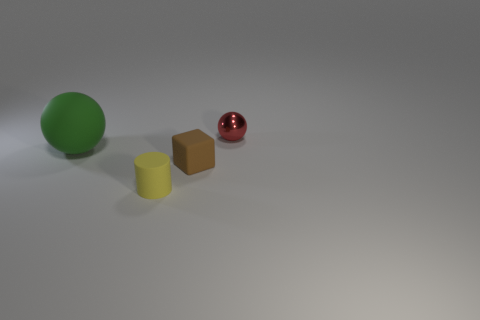Is there a cyan object that has the same size as the metal ball?
Your answer should be very brief. No. What is the material of the small thing that is right of the yellow thing and left of the red metallic sphere?
Make the answer very short. Rubber. How many shiny objects are either tiny blue cylinders or brown cubes?
Offer a very short reply. 0. There is another large object that is made of the same material as the brown thing; what is its shape?
Your answer should be compact. Sphere. What number of tiny matte objects are both in front of the tiny brown cube and behind the yellow rubber cylinder?
Give a very brief answer. 0. Are there any other things that are the same shape as the big green matte object?
Ensure brevity in your answer.  Yes. What is the size of the sphere behind the matte ball?
Provide a short and direct response. Small. What is the material of the sphere that is in front of the ball right of the big green matte object?
Your answer should be very brief. Rubber. Is there any other thing that is the same material as the red object?
Keep it short and to the point. No. How many small brown matte things have the same shape as the yellow rubber object?
Provide a short and direct response. 0. 